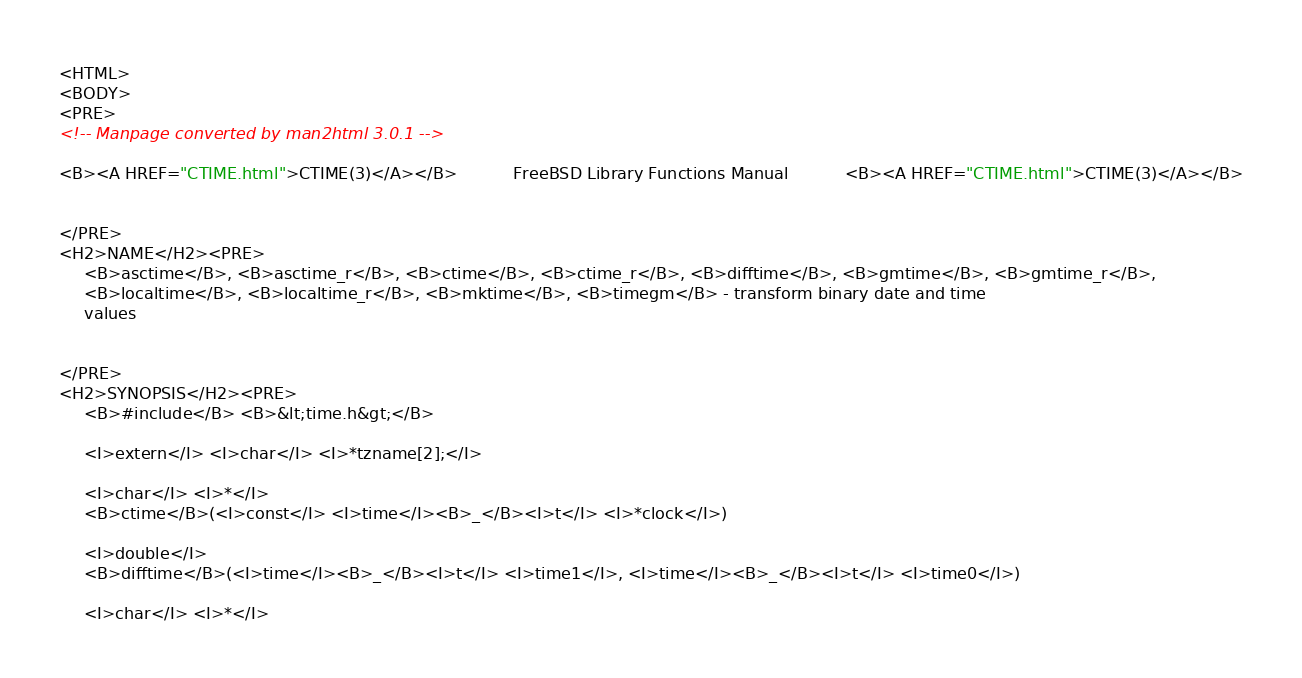<code> <loc_0><loc_0><loc_500><loc_500><_HTML_><HTML>
<BODY>
<PRE>
<!-- Manpage converted by man2html 3.0.1 -->

<B><A HREF="CTIME.html">CTIME(3)</A></B>	       FreeBSD Library Functions Manual 	      <B><A HREF="CTIME.html">CTIME(3)</A></B>


</PRE>
<H2>NAME</H2><PRE>
     <B>asctime</B>, <B>asctime_r</B>, <B>ctime</B>, <B>ctime_r</B>, <B>difftime</B>, <B>gmtime</B>, <B>gmtime_r</B>,
     <B>localtime</B>, <B>localtime_r</B>, <B>mktime</B>, <B>timegm</B> - transform binary date and time
     values


</PRE>
<H2>SYNOPSIS</H2><PRE>
     <B>#include</B> <B>&lt;time.h&gt;</B>

     <I>extern</I> <I>char</I> <I>*tzname[2];</I>

     <I>char</I> <I>*</I>
     <B>ctime</B>(<I>const</I> <I>time</I><B>_</B><I>t</I> <I>*clock</I>)

     <I>double</I>
     <B>difftime</B>(<I>time</I><B>_</B><I>t</I> <I>time1</I>, <I>time</I><B>_</B><I>t</I> <I>time0</I>)

     <I>char</I> <I>*</I></code> 